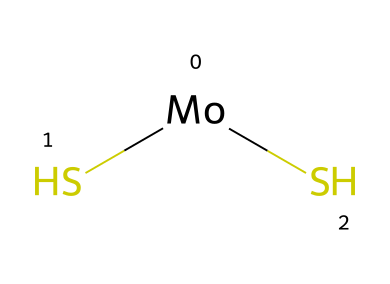What is the central metal atom in this structure? The SMILES representation shows a molybdenum atom, which is the central metal atom. In the structure, [Mo] indicates that molybdenum is at the center surrounded by sulfur atoms.
Answer: molybdenum How many sulfur atoms are bonded to the metal atom? The SMILES notation includes (S)(S), indicating that there are two sulfur atoms directly bonded to the molybdenum atom.
Answer: two What type of material is commonly made from this compound? Molybdenum disulfide is primarily used as a solid lubricant due to its layered structure, which allows for easy movement between the layers when subjected to shear forces.
Answer: lubricant What is the primary property of molybdenum disulfide that makes it suitable for aerospace applications? Molybdenum disulfide exhibits excellent lubrication properties at high temperatures and under high pressure, which is essential for components in aerospace applications that experience extreme conditions.
Answer: high-temperature resistance What is the molecular formula implied by the SMILES representation? The structure provides the number of atoms as indicated in the SMILES: one molybdenum and two sulfur atoms, which together represent the molecular formula MoS2.
Answer: MoS2 How does the structure of molybdenum disulfide contribute to its lubricating properties? Molybdenum disulfide has a layered hexagonal structure that allows the layers to slide over one another easily, reducing friction, which is a key property for a solid lubricant in various applications.
Answer: layered structure 